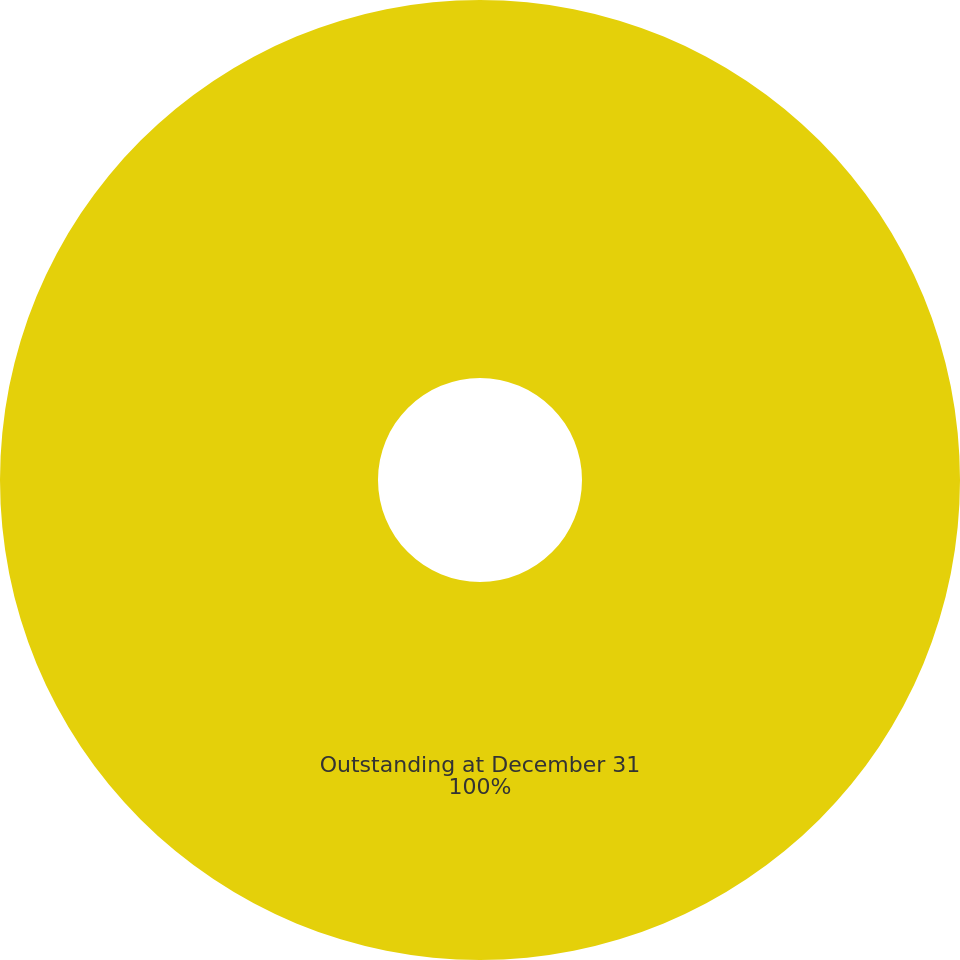<chart> <loc_0><loc_0><loc_500><loc_500><pie_chart><fcel>Outstanding at December 31<nl><fcel>100.0%<nl></chart> 